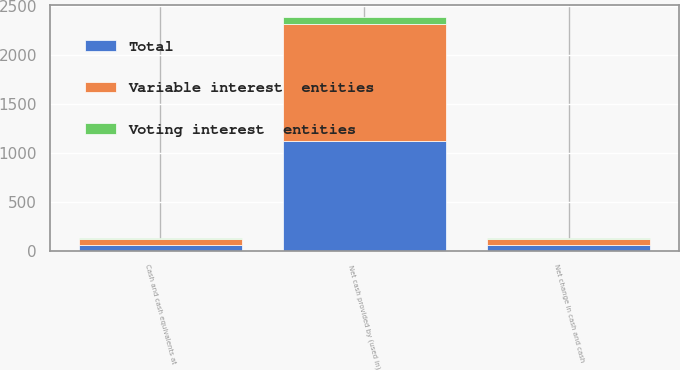Convert chart to OTSL. <chart><loc_0><loc_0><loc_500><loc_500><stacked_bar_chart><ecel><fcel>Net cash provided by (used in)<fcel>Net change in cash and cash<fcel>Cash and cash equivalents at<nl><fcel>Voting interest  entities<fcel>68.8<fcel>10.3<fcel>10.3<nl><fcel>Total<fcel>1124.1<fcel>55.3<fcel>55.3<nl><fcel>Variable interest  entities<fcel>1192.9<fcel>65.6<fcel>65.6<nl></chart> 